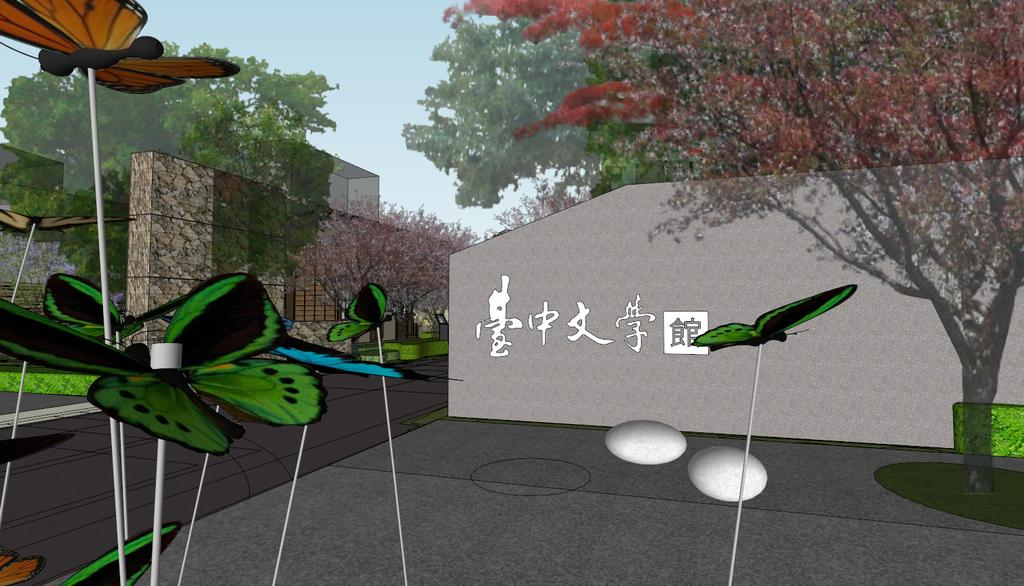What type of animals can be seen in the image? There are butterflies in the image. What other objects or items can be seen in the image? There are eggs in the image. What natural element is present in the image? There is a tree in the image. What can be seen in the background of the image? There are trees, a wall, and grass in the background of the image. What type of trucks can be seen in the image? There are no trucks present in the image. Can you tell me the color of the queen's dress in the image? There is no queen present in the image. 